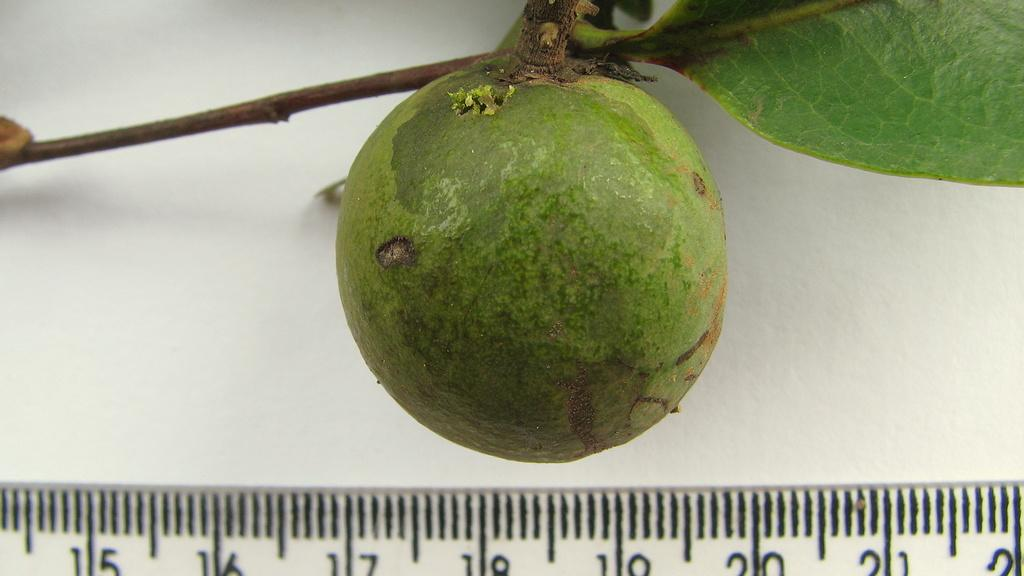What type of fruit is in the image? There is a guava fruit in the image. What part of the fruit is attached to the tree? The guava fruit has a stem. What type of plant material is visible in the image? There is a leaf in the image. What device is used to measure something in the image? There is a scale with readings in the image. What type of train can be seen in the image? There is no train present in the image; it features a guava fruit, a leaf, and a scale with readings. 